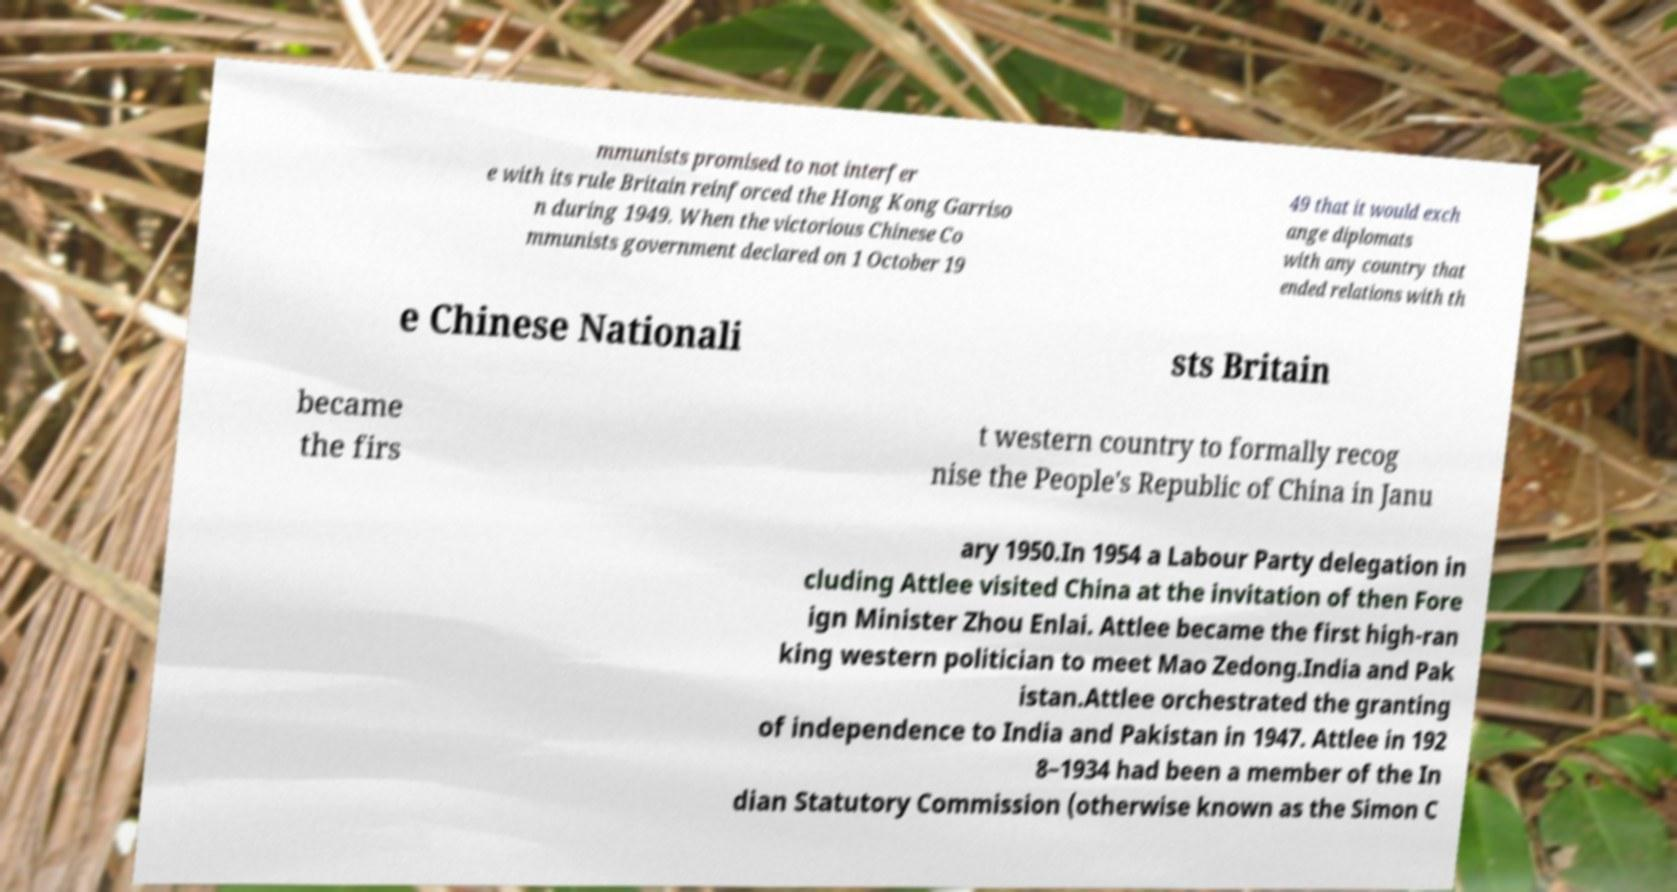Can you read and provide the text displayed in the image?This photo seems to have some interesting text. Can you extract and type it out for me? mmunists promised to not interfer e with its rule Britain reinforced the Hong Kong Garriso n during 1949. When the victorious Chinese Co mmunists government declared on 1 October 19 49 that it would exch ange diplomats with any country that ended relations with th e Chinese Nationali sts Britain became the firs t western country to formally recog nise the People's Republic of China in Janu ary 1950.In 1954 a Labour Party delegation in cluding Attlee visited China at the invitation of then Fore ign Minister Zhou Enlai. Attlee became the first high-ran king western politician to meet Mao Zedong.India and Pak istan.Attlee orchestrated the granting of independence to India and Pakistan in 1947. Attlee in 192 8–1934 had been a member of the In dian Statutory Commission (otherwise known as the Simon C 